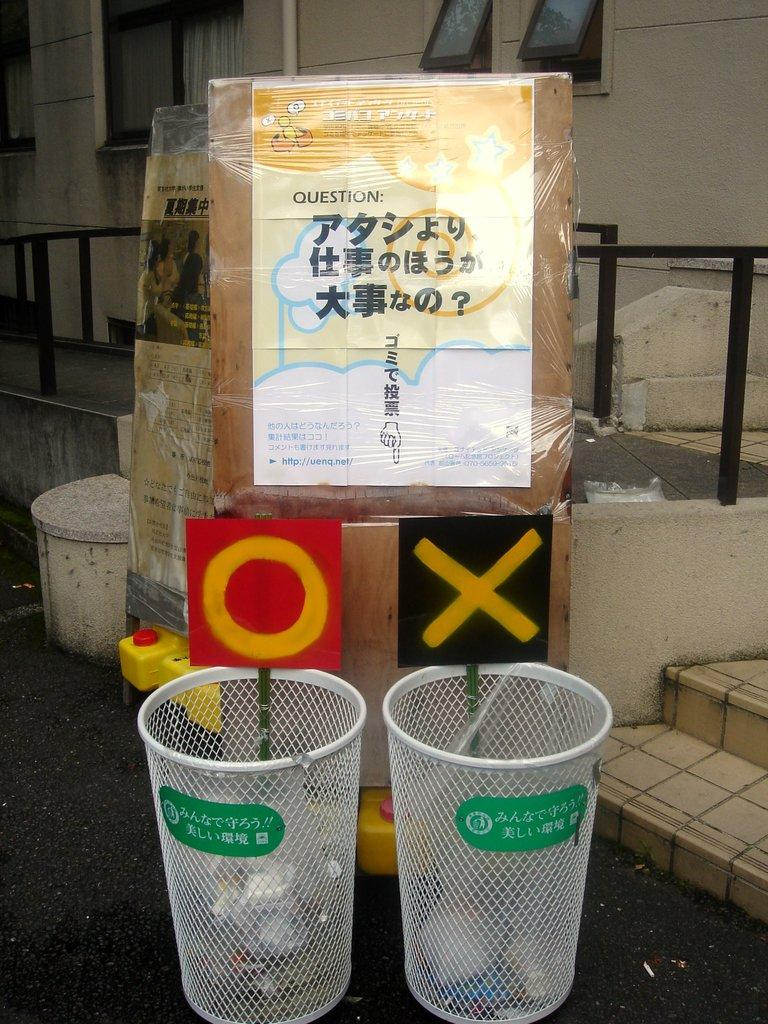<image>
Create a compact narrative representing the image presented. A plastic wrapped box says "Question" on it and points to and x & o bin. 